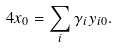<formula> <loc_0><loc_0><loc_500><loc_500>4 x _ { 0 } = \sum _ { i } \gamma _ { i } y _ { i 0 } .</formula> 